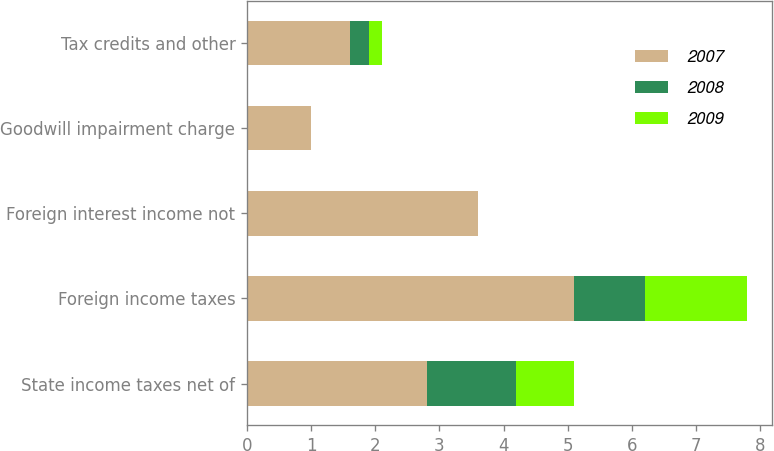<chart> <loc_0><loc_0><loc_500><loc_500><stacked_bar_chart><ecel><fcel>State income taxes net of<fcel>Foreign income taxes<fcel>Foreign interest income not<fcel>Goodwill impairment charge<fcel>Tax credits and other<nl><fcel>2007<fcel>2.8<fcel>5.1<fcel>3.6<fcel>1<fcel>1.6<nl><fcel>2008<fcel>1.4<fcel>1.1<fcel>0<fcel>0<fcel>0.3<nl><fcel>2009<fcel>0.9<fcel>1.6<fcel>0<fcel>0<fcel>0.2<nl></chart> 